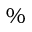<formula> <loc_0><loc_0><loc_500><loc_500>\%</formula> 